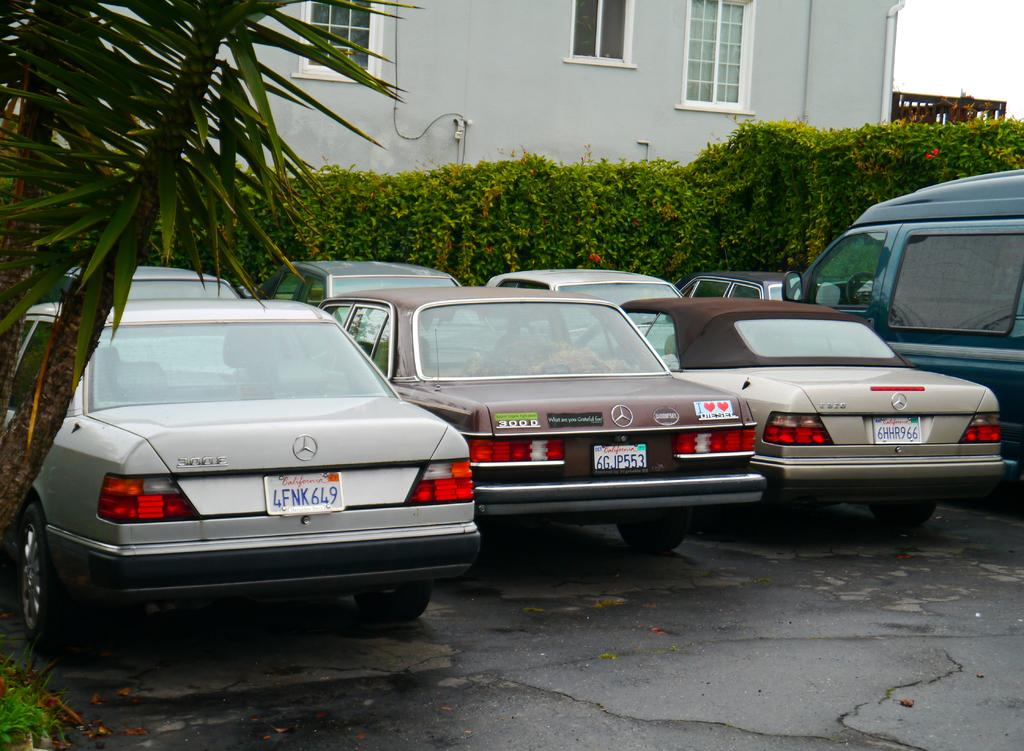What can be seen in the image related to transportation? There are cars parked in the image. Where are the cars located? The cars are in a parking area. What can be seen in the background of the image? There are plants and a house visible in the background of the image. What type of disease can be seen affecting the plants in the image? There is no disease affecting the plants in the image; they appear healthy. How does the stomach of the house in the image look? The image does not show the interior or any specific features of the house, so it is not possible to describe the appearance of the house's stomach. 